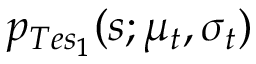<formula> <loc_0><loc_0><loc_500><loc_500>p _ { T e s _ { 1 } } ( s ; \mu _ { t } , \sigma _ { t } )</formula> 